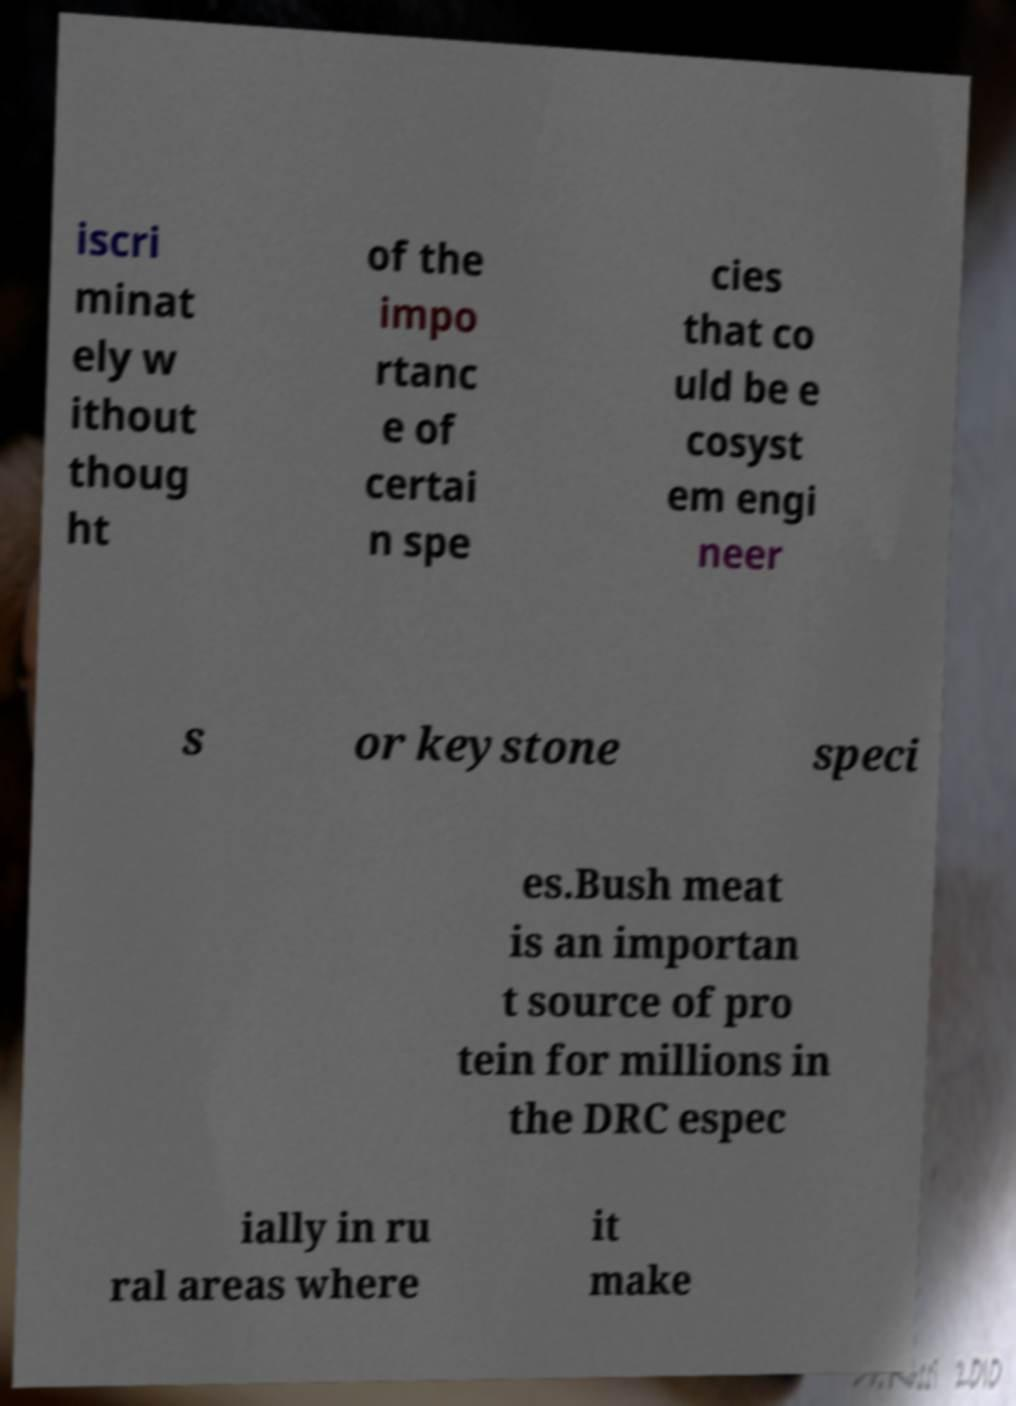What messages or text are displayed in this image? I need them in a readable, typed format. iscri minat ely w ithout thoug ht of the impo rtanc e of certai n spe cies that co uld be e cosyst em engi neer s or keystone speci es.Bush meat is an importan t source of pro tein for millions in the DRC espec ially in ru ral areas where it make 